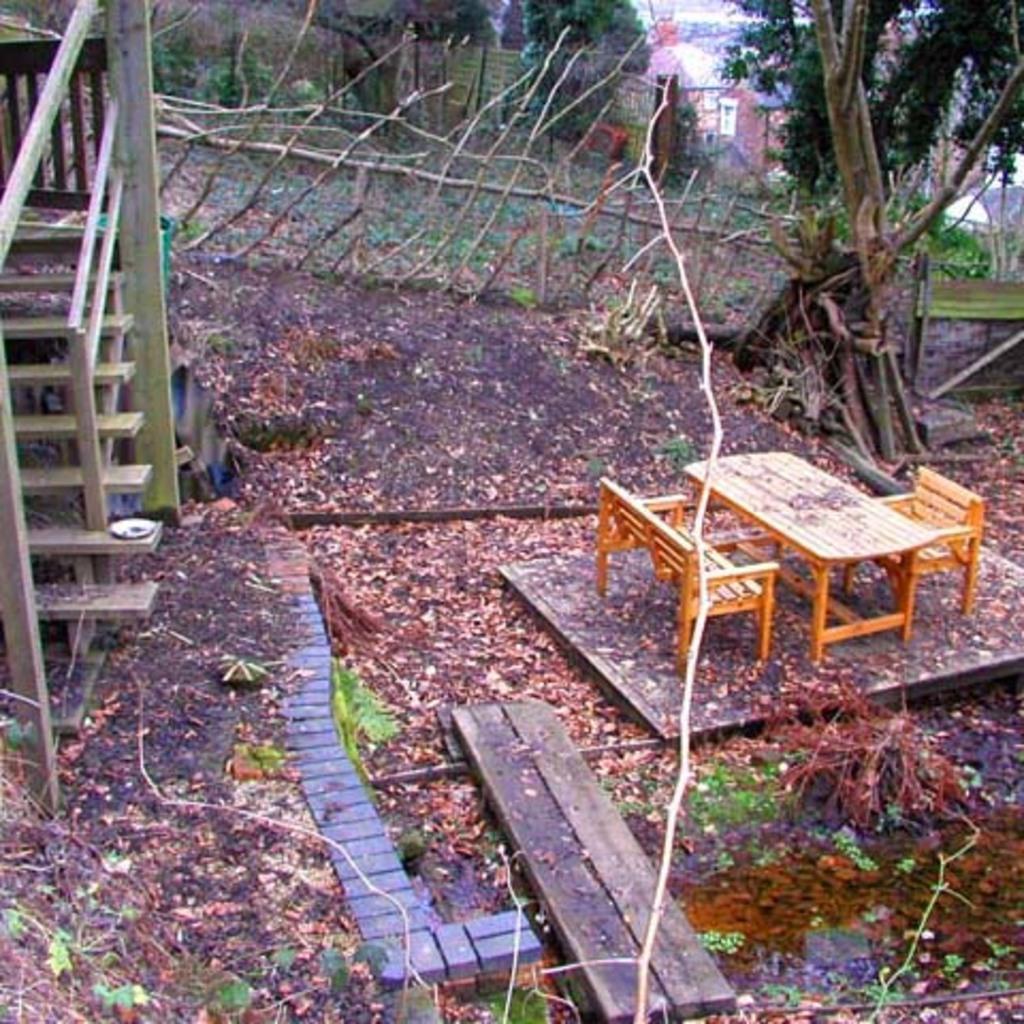Could you give a brief overview of what you see in this image? This image is taken outdoors. At the bottom of the image there is a ground with grass and many dry leaves on it. On the left side of the image there is a staircase and a railing. In the middle of the image there are a few trees, plants and a fence with wooden sticks and there is a table and three empty chairs on the floor. 